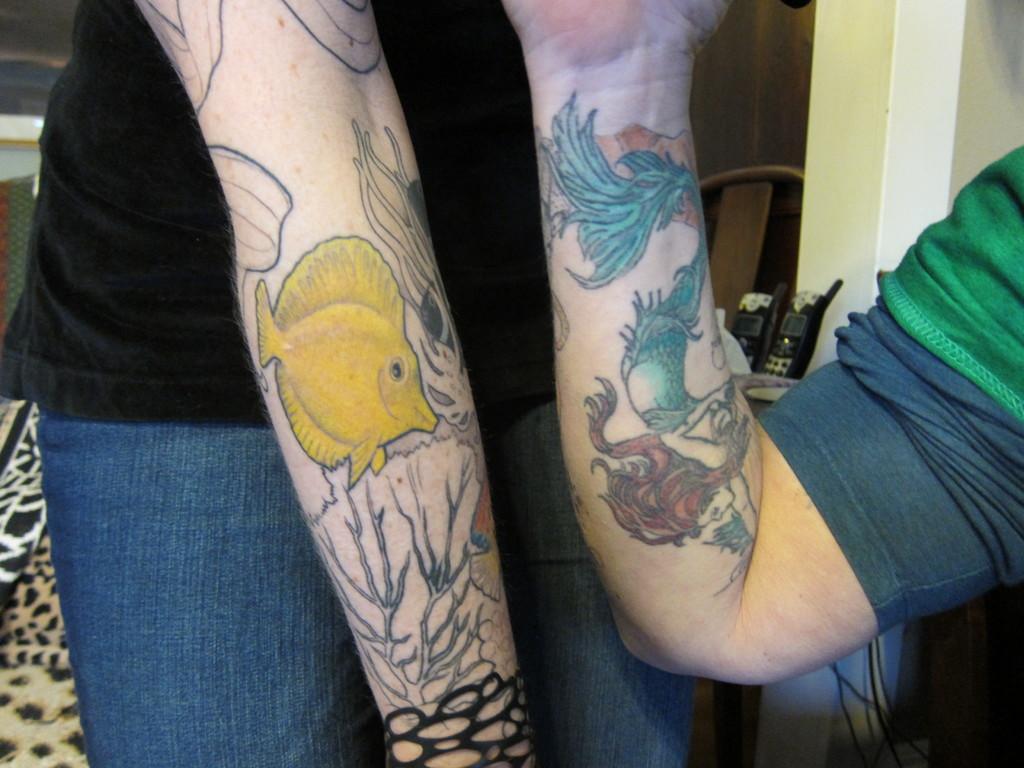Describe this image in one or two sentences. In the picture I can see two people on their hands there are few tattoos. 